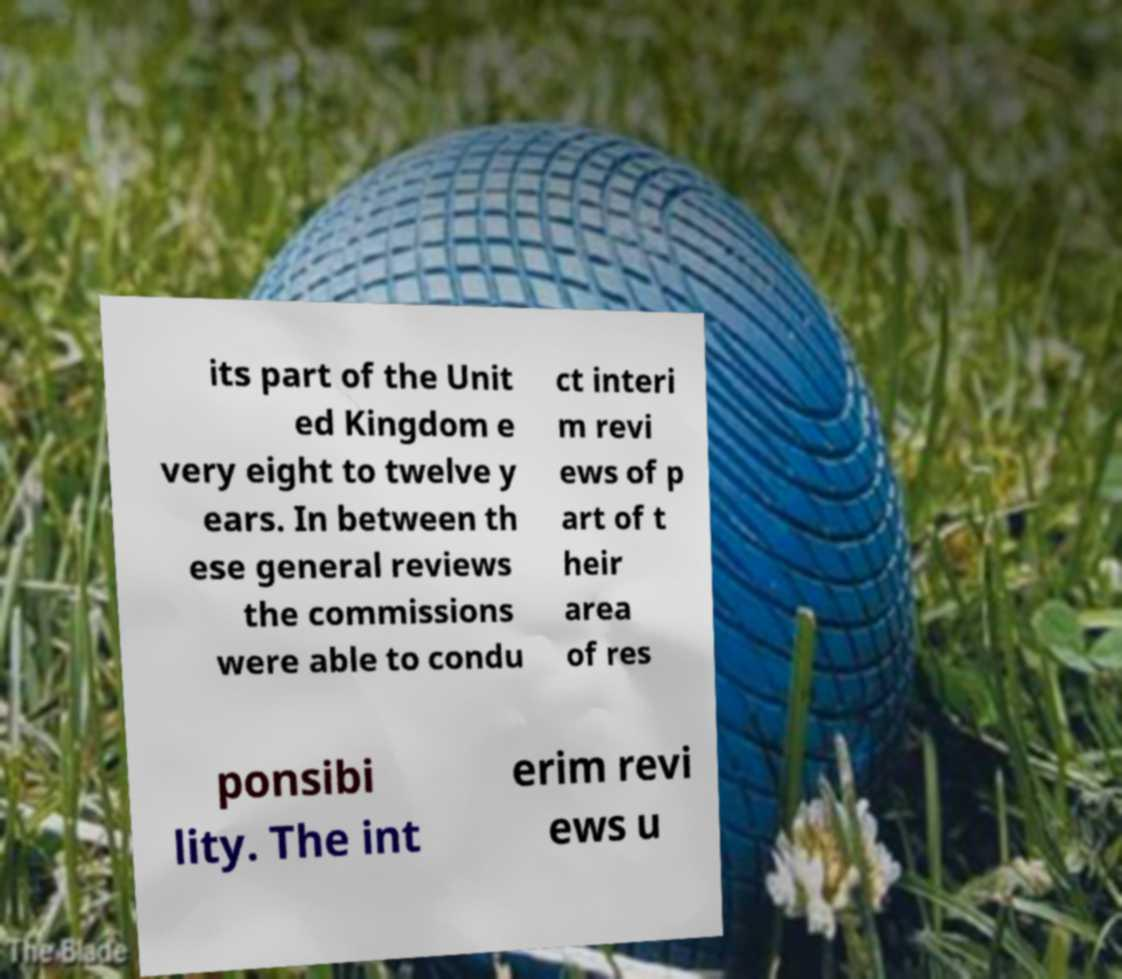For documentation purposes, I need the text within this image transcribed. Could you provide that? its part of the Unit ed Kingdom e very eight to twelve y ears. In between th ese general reviews the commissions were able to condu ct interi m revi ews of p art of t heir area of res ponsibi lity. The int erim revi ews u 